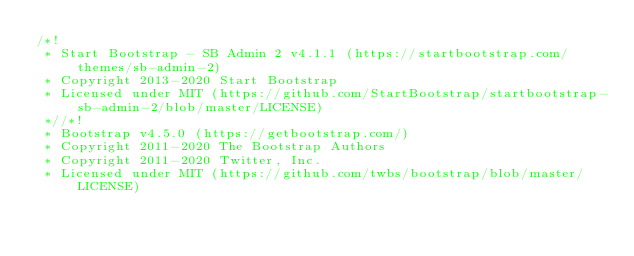Convert code to text. <code><loc_0><loc_0><loc_500><loc_500><_CSS_>/*!
 * Start Bootstrap - SB Admin 2 v4.1.1 (https://startbootstrap.com/themes/sb-admin-2)
 * Copyright 2013-2020 Start Bootstrap
 * Licensed under MIT (https://github.com/StartBootstrap/startbootstrap-sb-admin-2/blob/master/LICENSE)
 *//*!
 * Bootstrap v4.5.0 (https://getbootstrap.com/)
 * Copyright 2011-2020 The Bootstrap Authors
 * Copyright 2011-2020 Twitter, Inc.
 * Licensed under MIT (https://github.com/twbs/bootstrap/blob/master/LICENSE)</code> 